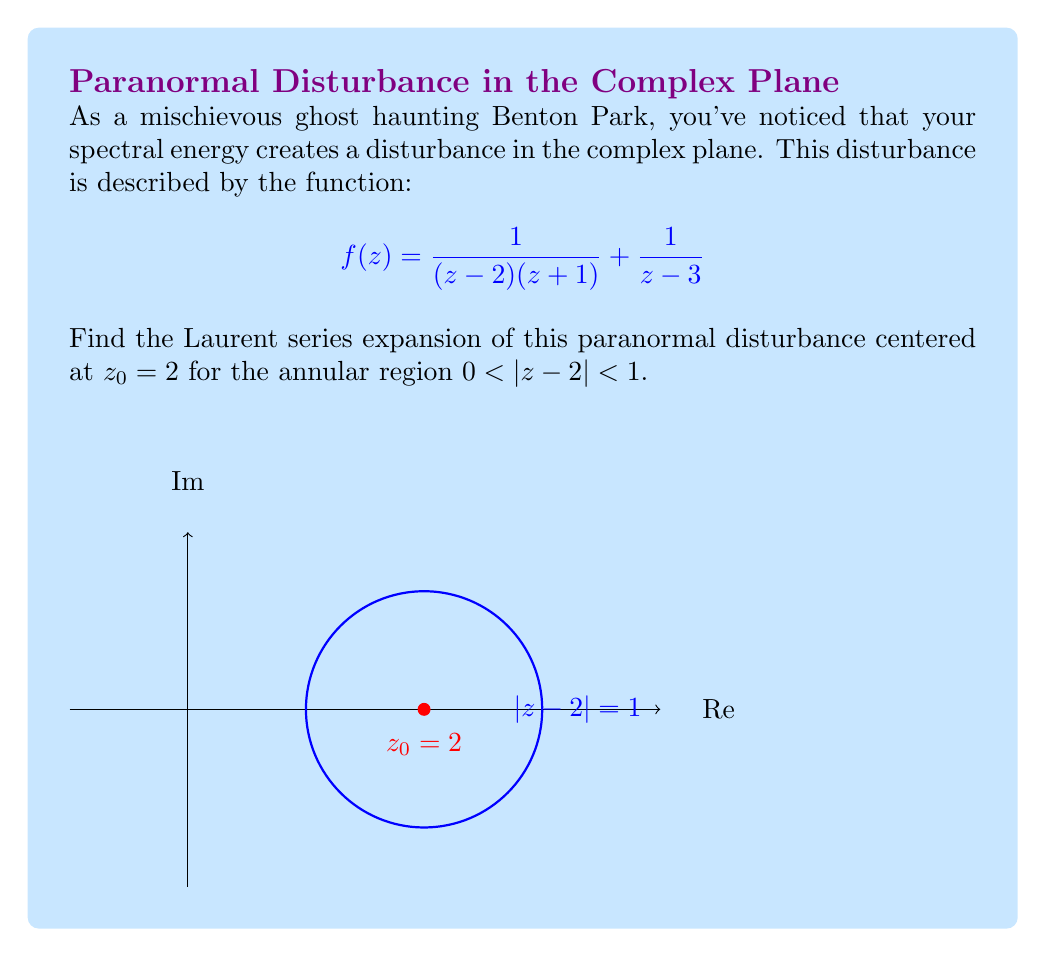Can you answer this question? To find the Laurent series expansion, we'll follow these steps:

1) First, we need to separate the function into partial fractions:

   $$f(z) = \frac{1}{(z-2)(z+1)} + \frac{1}{z-3} = \frac{A}{z-2} + \frac{B}{z+1} + \frac{1}{z-3}$$

   where $A$ and $B$ are constants to be determined.

2) Solving for $A$ and $B$:
   
   $$A(z+1) + B(z-2) = 1$$
   
   When $z = 2$: $3A = 1$, so $A = \frac{1}{3}$
   When $z = -1$: $-3B = 1$, so $B = -\frac{1}{3}$

3) Now our function is:

   $$f(z) = \frac{1/3}{z-2} - \frac{1/3}{z+1} + \frac{1}{z-3}$$

4) For the term $\frac{1/3}{z-2}$, we can directly use the geometric series:

   $$\frac{1/3}{z-2} = \frac{1/3}{-(-(z-2))} = -\frac{1}{3} \sum_{n=0}^{\infty} (z-2)^{-(n+1)}$$

5) For $-\frac{1/3}{z+1}$, we can rewrite it as:

   $$-\frac{1/3}{z+1} = -\frac{1/3}{(z-2)+3} = -\frac{1/3}{3(1+\frac{z-2}{3})} = -\frac{1}{9} \sum_{n=0}^{\infty} (-1)^n \frac{(z-2)^n}{3^n}$$

6) For $\frac{1}{z-3}$, we can rewrite it as:

   $$\frac{1}{z-3} = \frac{1}{(z-2)-1} = -\sum_{n=0}^{\infty} (z-2)^n$$

7) Combining all terms:

   $$f(z) = -\frac{1}{3} \sum_{n=0}^{\infty} (z-2)^{-(n+1)} - \frac{1}{9} \sum_{n=0}^{\infty} (-1)^n \frac{(z-2)^n}{3^n} - \sum_{n=0}^{\infty} (z-2)^n$$

This is the Laurent series expansion of $f(z)$ centered at $z_0 = 2$ for $0 < |z-2| < 1$.
Answer: $$f(z) = -\frac{1}{3} \sum_{n=0}^{\infty} (z-2)^{-(n+1)} - \frac{1}{9} \sum_{n=0}^{\infty} (-1)^n \frac{(z-2)^n}{3^n} - \sum_{n=0}^{\infty} (z-2)^n$$ 